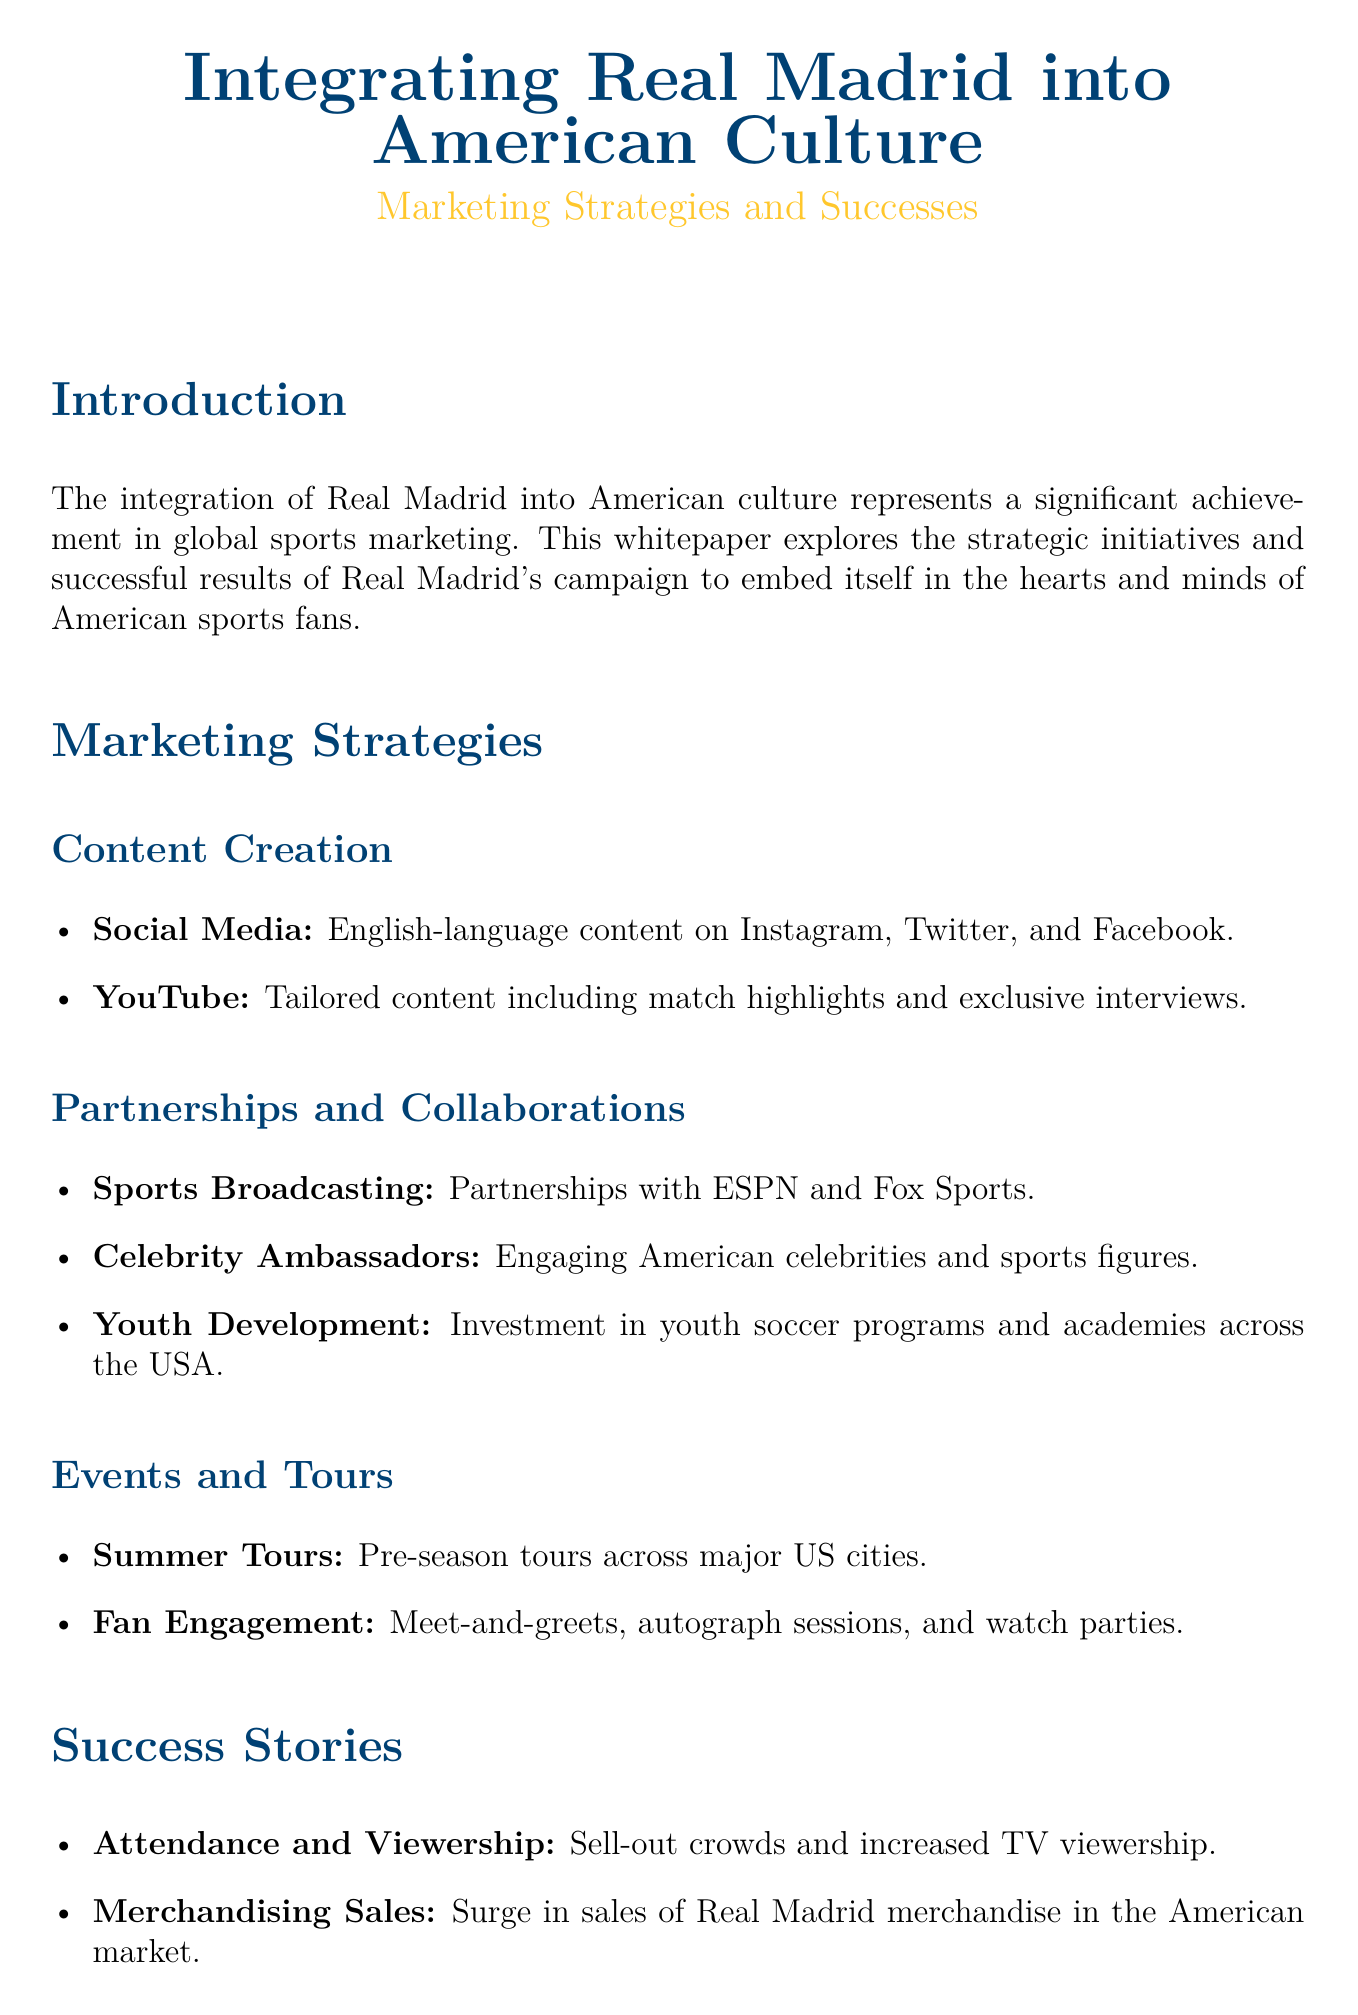what is the title of the whitepaper? The title is displayed prominently at the beginning of the document.
Answer: Integrating Real Madrid into American Culture who is the author of the whitepaper? The author is credited at the end of the document.
Answer: a loyal Real Madrid fan living in the United States what marketing strategy involves partnerships with sports networks? This strategy is outlined under partnerships and collaborations.
Answer: Sports Broadcasting what type of content is highlighted for YouTube? The document specifies the nature of tailored content for YouTube.
Answer: Match highlights and exclusive interviews what is one success story mentioned in the document? A specific success story cited in the document refers to audience engagement.
Answer: Sell-out crowds how has merchandise sales changed according to the whitepaper? The whitepaper indicates a particular trend in merchandise sales.
Answer: Surge what kind of events does Real Madrid organize in the US? This question refers to the events categorized under tours visible in the document.
Answer: Summer Tours what color is associated with Real Madrid in this document? This refers to the color coding used in the title section.
Answer: Madrid blue 